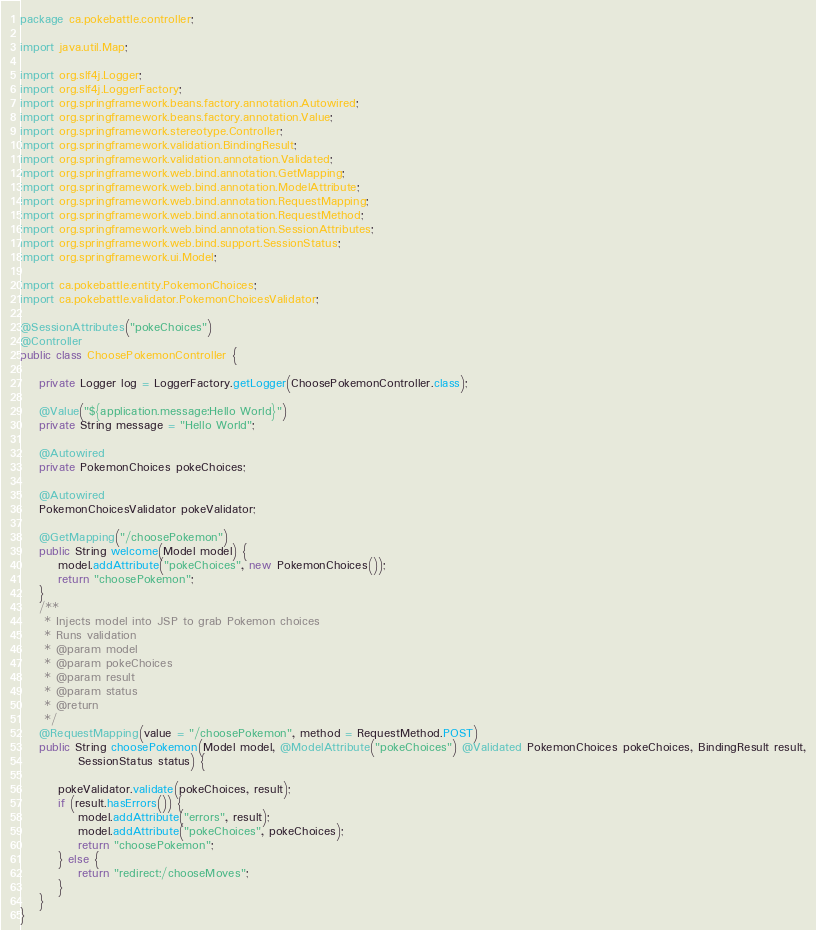Convert code to text. <code><loc_0><loc_0><loc_500><loc_500><_Java_>package ca.pokebattle.controller;

import java.util.Map;

import org.slf4j.Logger;
import org.slf4j.LoggerFactory;
import org.springframework.beans.factory.annotation.Autowired;
import org.springframework.beans.factory.annotation.Value;
import org.springframework.stereotype.Controller;
import org.springframework.validation.BindingResult;
import org.springframework.validation.annotation.Validated;
import org.springframework.web.bind.annotation.GetMapping;
import org.springframework.web.bind.annotation.ModelAttribute;
import org.springframework.web.bind.annotation.RequestMapping;
import org.springframework.web.bind.annotation.RequestMethod;
import org.springframework.web.bind.annotation.SessionAttributes;
import org.springframework.web.bind.support.SessionStatus;
import org.springframework.ui.Model;

import ca.pokebattle.entity.PokemonChoices;
import ca.pokebattle.validator.PokemonChoicesValidator;

@SessionAttributes("pokeChoices")
@Controller
public class ChoosePokemonController {

	private Logger log = LoggerFactory.getLogger(ChoosePokemonController.class);

	@Value("${application.message:Hello World}")
	private String message = "Hello World";

	@Autowired
	private PokemonChoices pokeChoices;
	
	@Autowired
	PokemonChoicesValidator pokeValidator;

	@GetMapping("/choosePokemon")
	public String welcome(Model model) {
		model.addAttribute("pokeChoices", new PokemonChoices());
		return "choosePokemon";
	}
	/**
	 * Injects model into JSP to grab Pokemon choices
	 * Runs validation
	 * @param model
	 * @param pokeChoices
	 * @param result
	 * @param status
	 * @return
	 */
	@RequestMapping(value = "/choosePokemon", method = RequestMethod.POST)
	public String choosePokemon(Model model, @ModelAttribute("pokeChoices") @Validated PokemonChoices pokeChoices, BindingResult result,
			SessionStatus status) {
		
		pokeValidator.validate(pokeChoices, result);
		if (result.hasErrors()) {
			model.addAttribute("errors", result);
			model.addAttribute("pokeChoices", pokeChoices);
			return "choosePokemon";
		} else {
			return "redirect:/chooseMoves";
		}
	}
}
</code> 